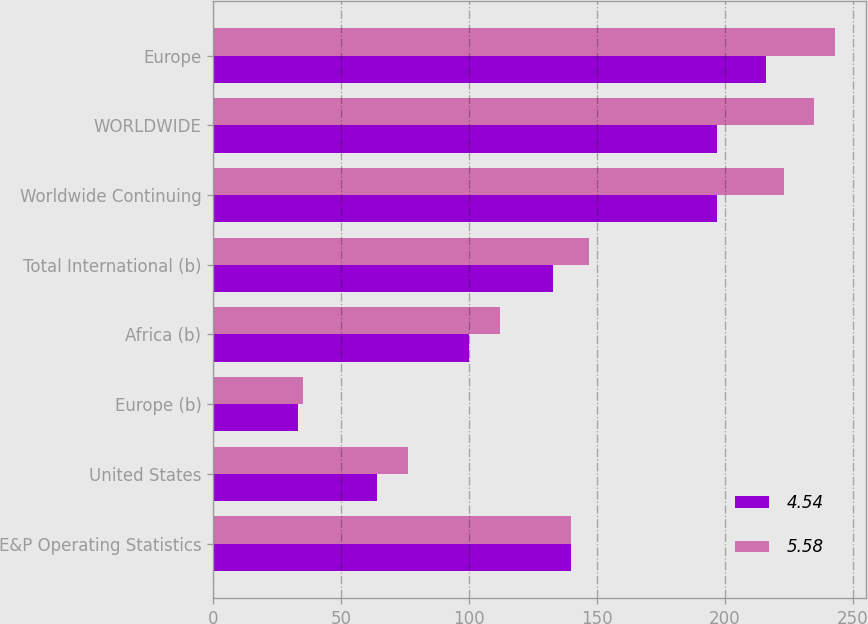Convert chart. <chart><loc_0><loc_0><loc_500><loc_500><stacked_bar_chart><ecel><fcel>E&P Operating Statistics<fcel>United States<fcel>Europe (b)<fcel>Africa (b)<fcel>Total International (b)<fcel>Worldwide Continuing<fcel>WORLDWIDE<fcel>Europe<nl><fcel>4.54<fcel>140<fcel>64<fcel>33<fcel>100<fcel>133<fcel>197<fcel>197<fcel>216<nl><fcel>5.58<fcel>140<fcel>76<fcel>35<fcel>112<fcel>147<fcel>223<fcel>235<fcel>243<nl></chart> 